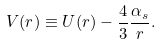<formula> <loc_0><loc_0><loc_500><loc_500>V ( r ) \equiv U ( r ) - \frac { 4 } { 3 } \frac { \alpha _ { s } } { r } .</formula> 